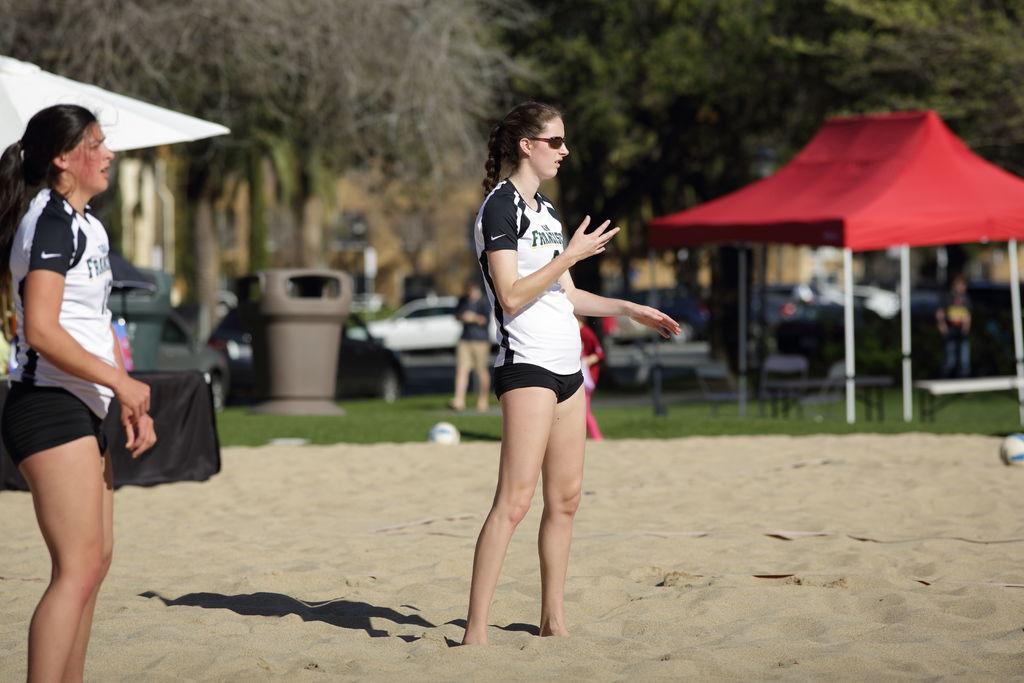How would you summarize this image in a sentence or two? In he center there is a woman who is wearing, goggle, t-shirt and short. On the left we can see a another woman who is wearing t-shirt and short. Both of them were standing on the sand. On the background we can see vehicles, dustbin, trees, persons and other objects. On the right we can see of benches under the red color shade. Here we can see grass. 